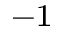Convert formula to latex. <formula><loc_0><loc_0><loc_500><loc_500>^ { - 1 }</formula> 